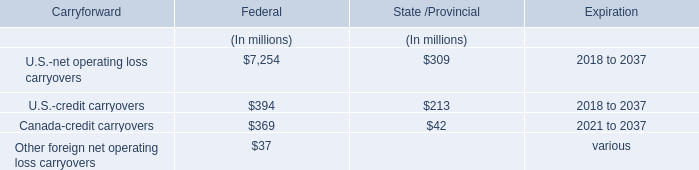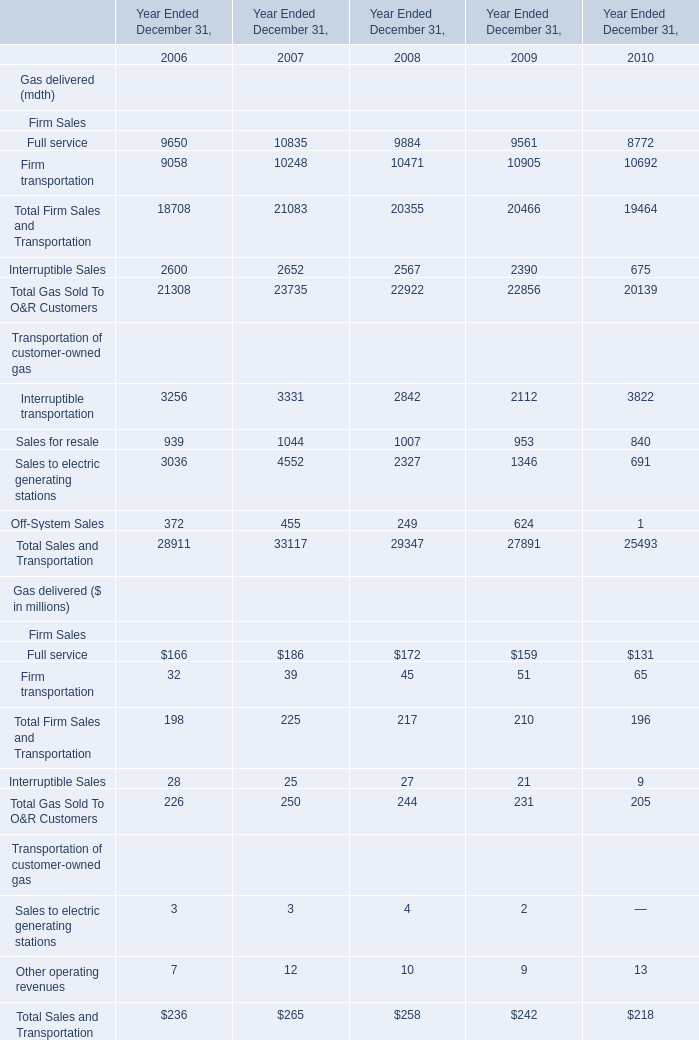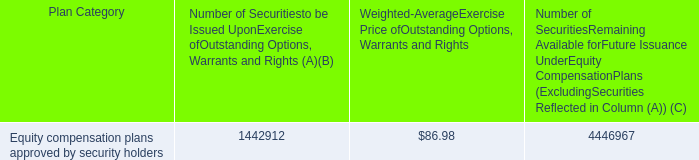In the year with largest amount of Full service for Gas delivered ($ in millions), what's the increasing rate of Firm transportation for Gas delivered ($ in millions? 
Computations: ((39 - 45) / 45)
Answer: -0.13333. 